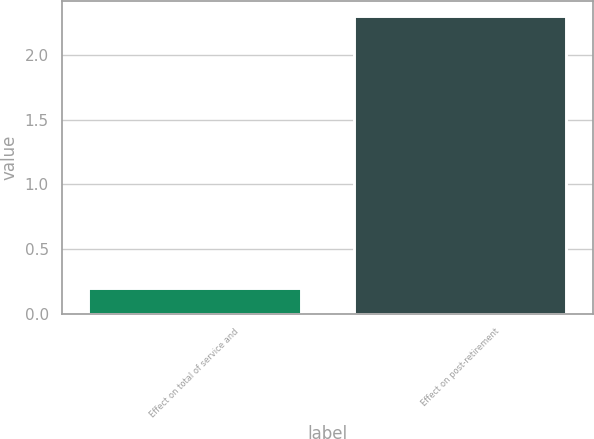Convert chart to OTSL. <chart><loc_0><loc_0><loc_500><loc_500><bar_chart><fcel>Effect on total of service and<fcel>Effect on post-retirement<nl><fcel>0.2<fcel>2.3<nl></chart> 